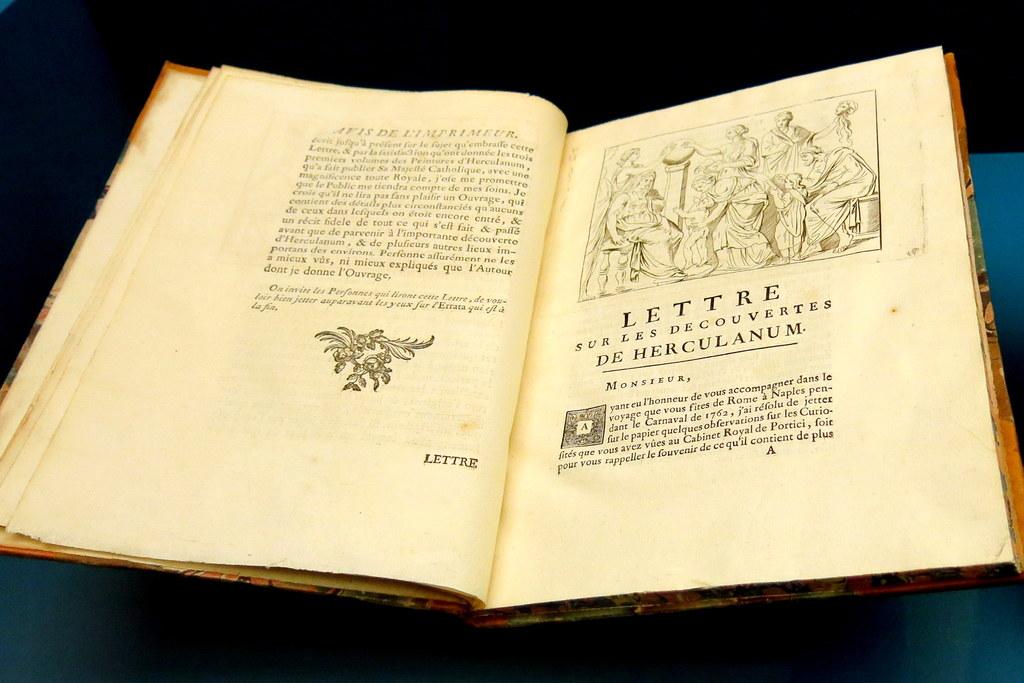Is the book written in english?
Provide a short and direct response. No. 